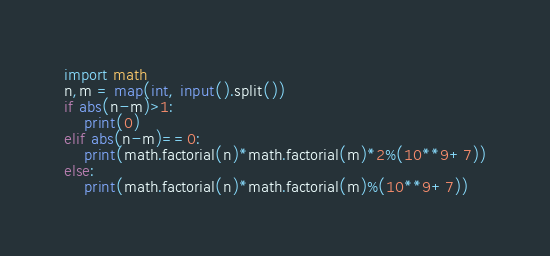<code> <loc_0><loc_0><loc_500><loc_500><_Python_>import math
n,m = map(int, input().split())
if abs(n-m)>1:
    print(0)
elif abs(n-m)==0:
    print(math.factorial(n)*math.factorial(m)*2%(10**9+7))
else:
    print(math.factorial(n)*math.factorial(m)%(10**9+7))
</code> 